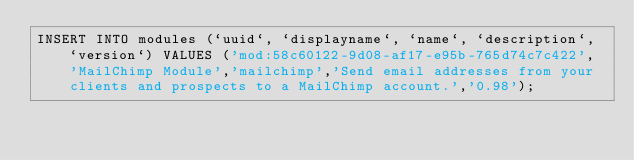Convert code to text. <code><loc_0><loc_0><loc_500><loc_500><_SQL_>INSERT INTO modules (`uuid`, `displayname`, `name`, `description`, `version`) VALUES ('mod:58c60122-9d08-af17-e95b-765d74c7c422', 'MailChimp Module','mailchimp','Send email addresses from your clients and prospects to a MailChimp account.','0.98');</code> 